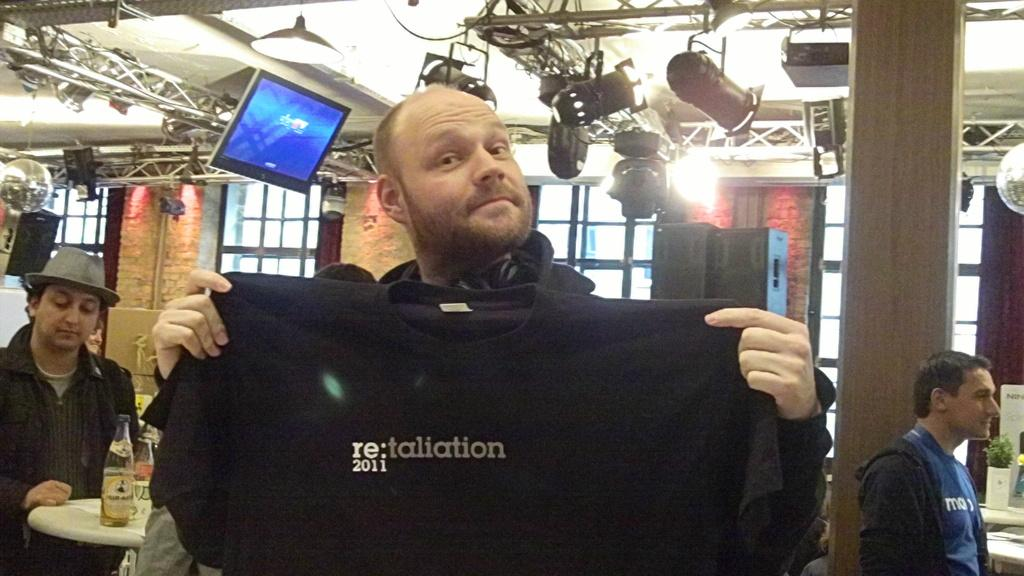What is the person in the image holding? The person is holding a shirt in the image. What can be seen in the background of the image? There are people, tables, lights on the roof, and television screens visible in the background of the image. Can you describe the setting of the image? The image appears to be set in a store or showroom, with tables displaying merchandise and people in the background. What type of secretary can be seen helping customers in the image? There is no secretary present in the image; it only shows a person holding a shirt and the background setting. 